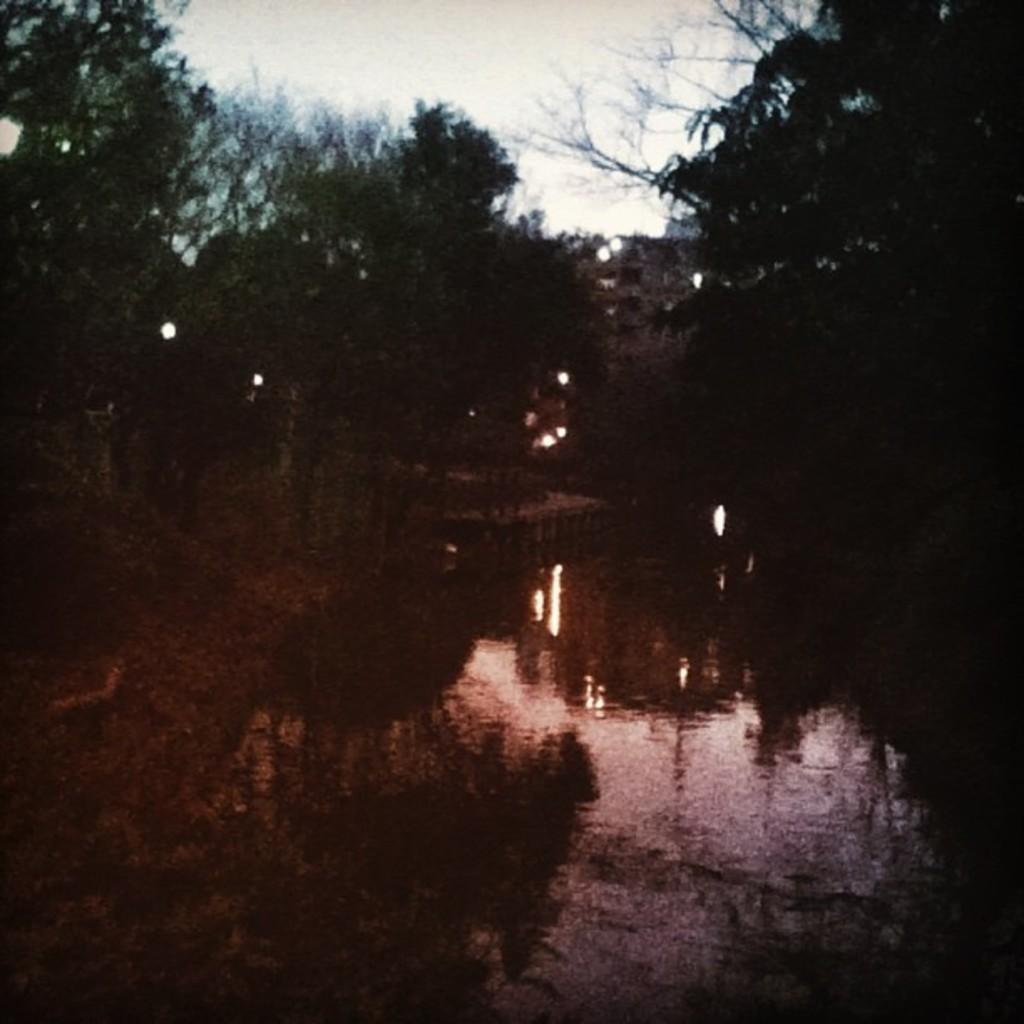What type of natural feature is present in the image? There is a lake in the image. What can be seen in the middle of the image? There are trees in the middle of the image. What is visible at the top of the image? The sky is visible at the top of the image. Where is the nearest hospital to the lake in the image? The image does not provide information about the location of a hospital or any other man-made structures. 